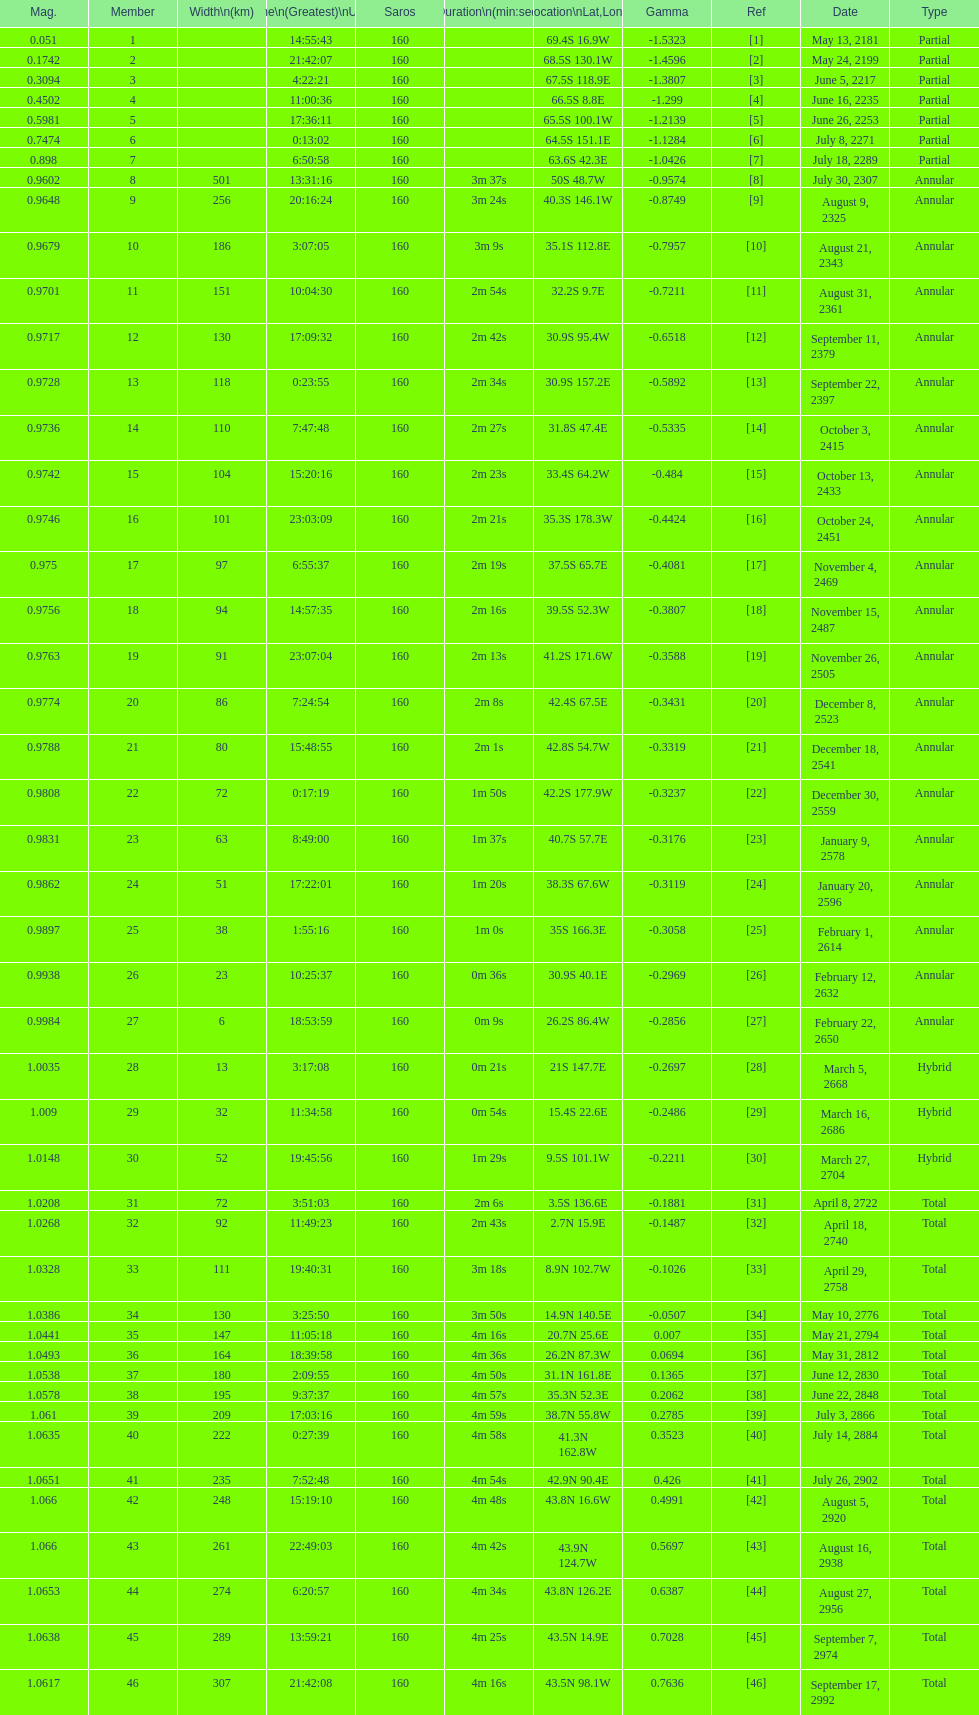How long did 18 last? 2m 16s. 